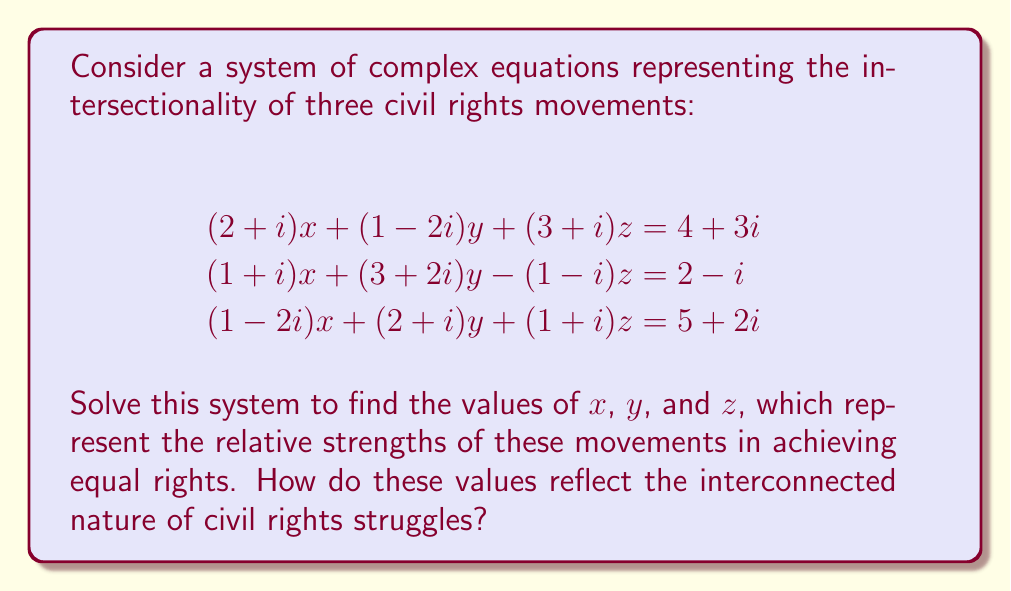Help me with this question. Let's solve this system using Gaussian elimination:

1) First, write the augmented matrix:
   $$\begin{bmatrix}
   2+i & 1-2i & 3+i & 4+3i \\
   1+i & 3+2i & -1+i & 2-i \\
   1-2i & 2+i & 1+i & 5+2i
   \end{bmatrix}$$

2) Multiply the first row by $(-1-i)$ and add to the second row:
   $$\begin{bmatrix}
   2+i & 1-2i & 3+i & 4+3i \\
   0 & 5+5i & -5+i & -3-6i \\
   1-2i & 2+i & 1+i & 5+2i
   \end{bmatrix}$$

3) Multiply the first row by $(-1+2i)$ and add to the third row:
   $$\begin{bmatrix}
   2+i & 1-2i & 3+i & 4+3i \\
   0 & 5+5i & -5+i & -3-6i \\
   0 & 3+7i & -3-i & 3-7i
   \end{bmatrix}$$

4) Multiply the second row by $\frac{3+7i}{5+5i}$ and subtract from the third row:
   $$\begin{bmatrix}
   2+i & 1-2i & 3+i & 4+3i \\
   0 & 5+5i & -5+i & -3-6i \\
   0 & 0 & -1-2i & 2-3i
   \end{bmatrix}$$

5) Now we can solve by back-substitution:
   $z = \frac{2-3i}{-1-2i} = 1+i$
   
   $y = \frac{(-3-6i) - (-5+i)(1+i)}{5+5i} = 1$
   
   $x = \frac{(4+3i) - (1-2i)(1) - (3+i)(1+i)}{2+i} = 1-i$

The solution $(x,y,z) = (1-i, 1, 1+i)$ represents the relative strengths of three interconnected civil rights movements. The real parts show equal strength (1), while the imaginary parts indicate how these movements influence each other: $x$ has a negative influence, $z$ has a positive influence, and $y$ is neutral. This reflects the complex, interconnected nature of civil rights struggles, where progress in one area can both positively and negatively impact others.
Answer: $(x,y,z) = (1-i, 1, 1+i)$ 